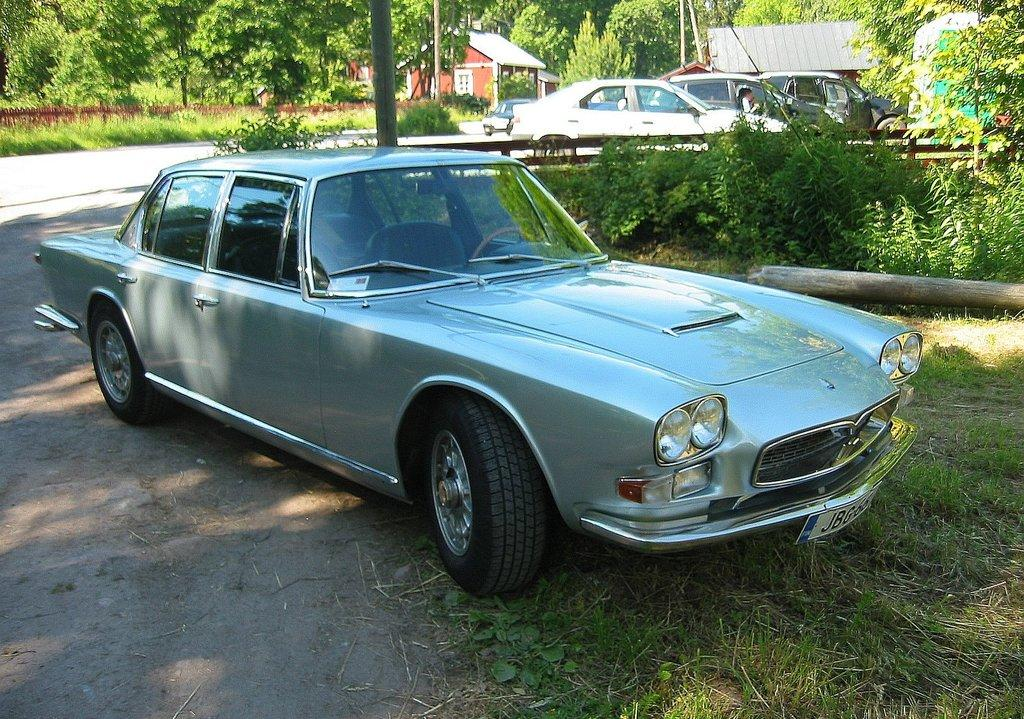What is: What is the main subject of the image? There is a car in the image. What is the ground covered with in the image? Green grass is present on the ground. What can be seen in the background of the image? There are many cars and trees visible in the background. Is there any other structure besides the car in the image? Yes, there is a small house to the left. Can you see a clam holding a whip in the image? No, there is no clam or whip present in the image. Is there a bag hanging from the tree in the background? There is no bag mentioned or visible in the image; only trees are mentioned in the background. 